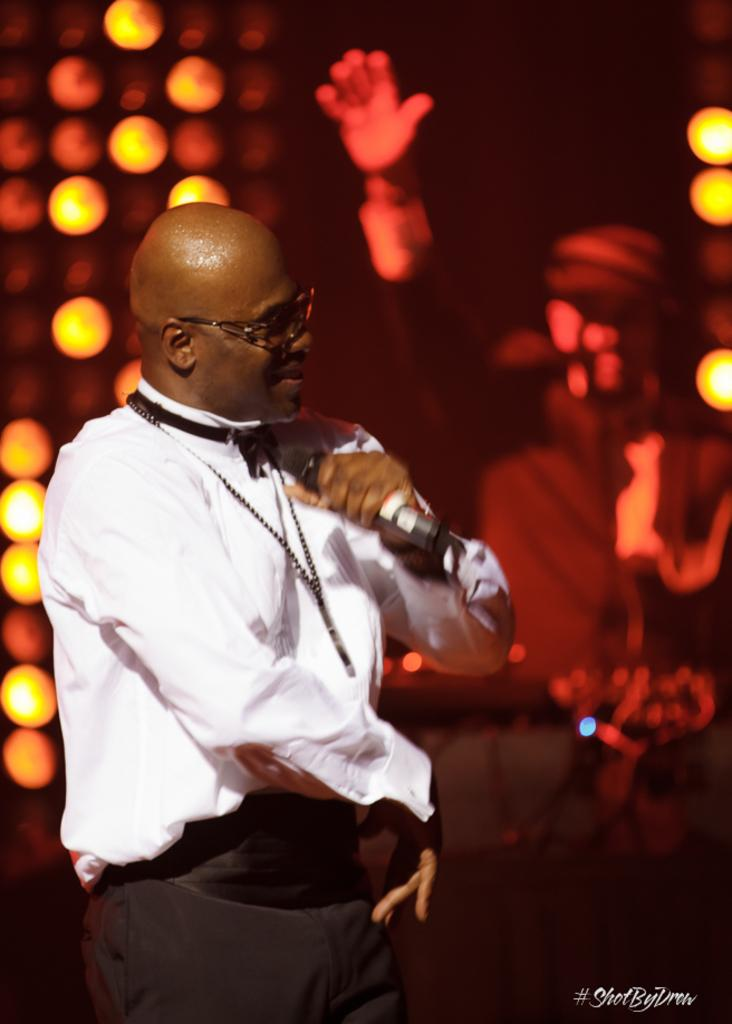What is the man in the image holding? The man is holding a microphone. Can you describe the man's appearance in the image? The man is wearing spectacles. What is happening in the background of the image? There is a person in the background with their hands lifted, and there are lights visible. What type of leather is the man's dad using to make a car seat in the image? There is no mention of a car, leather, or the man's dad in the image, so this information cannot be determined. 